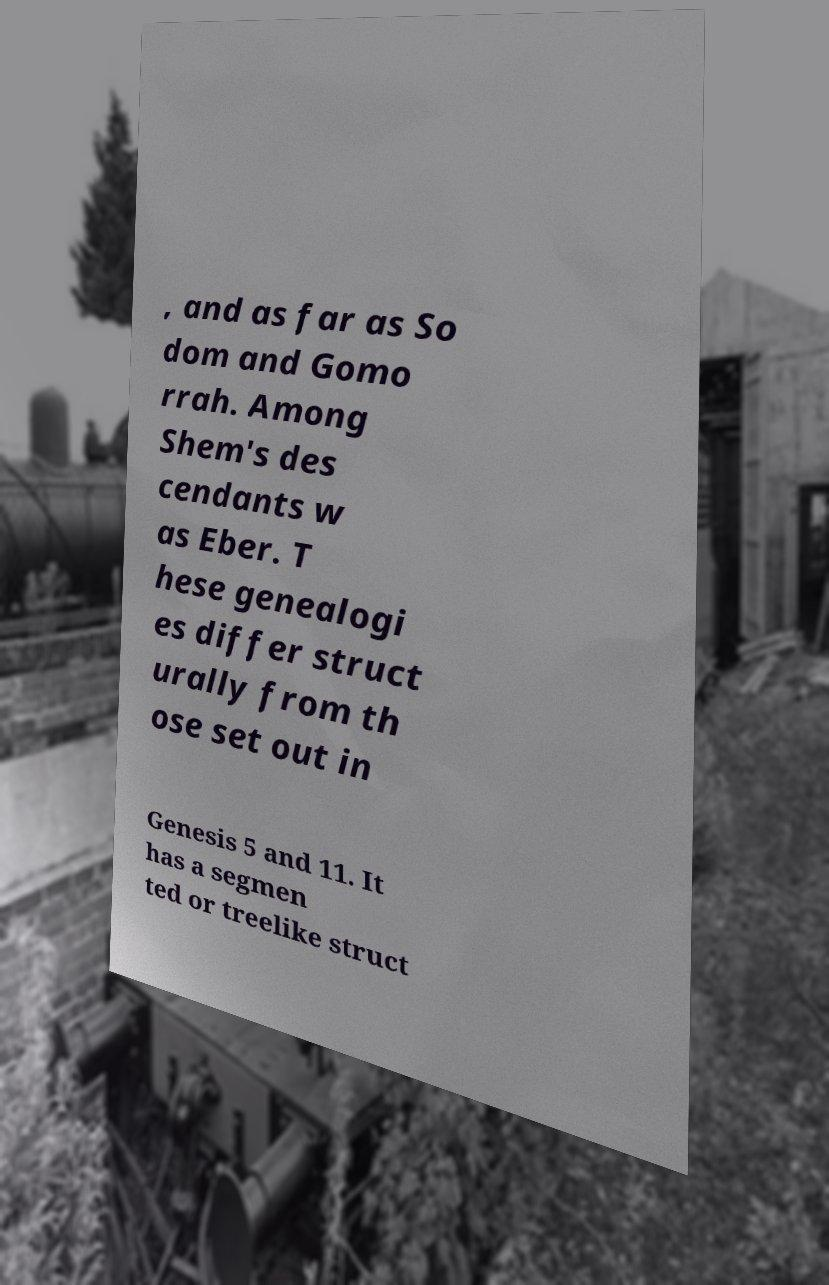Please read and relay the text visible in this image. What does it say? , and as far as So dom and Gomo rrah. Among Shem's des cendants w as Eber. T hese genealogi es differ struct urally from th ose set out in Genesis 5 and 11. It has a segmen ted or treelike struct 